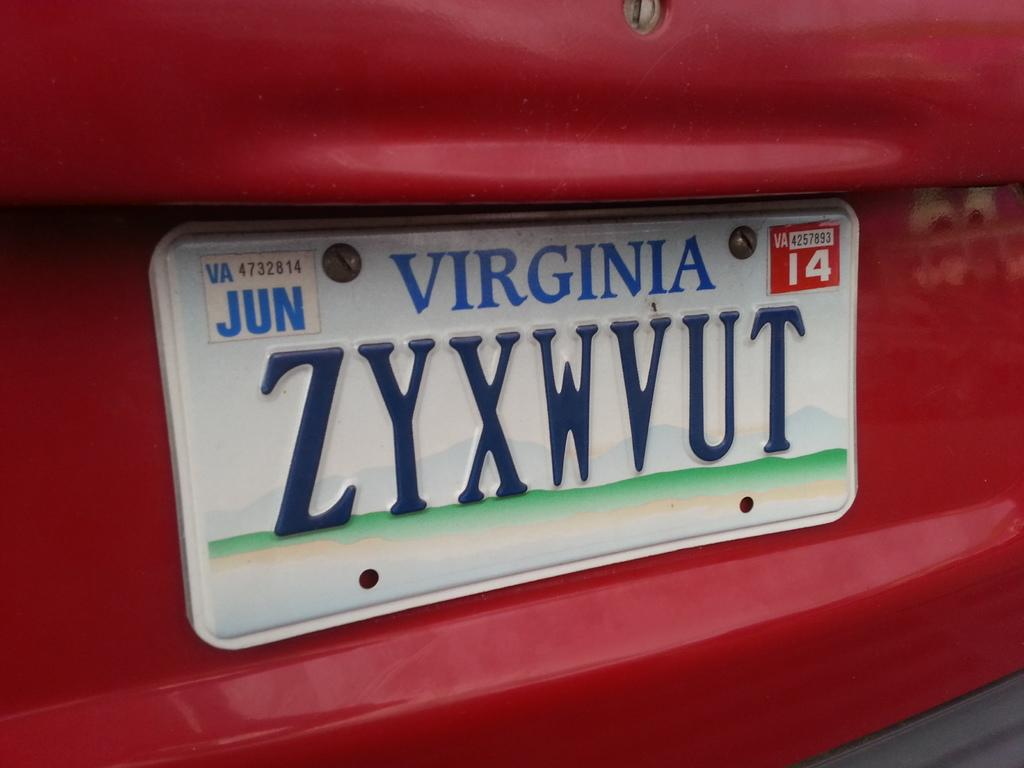Provide a one-sentence caption for the provided image. A Virginia license plate on a red vehicle. 